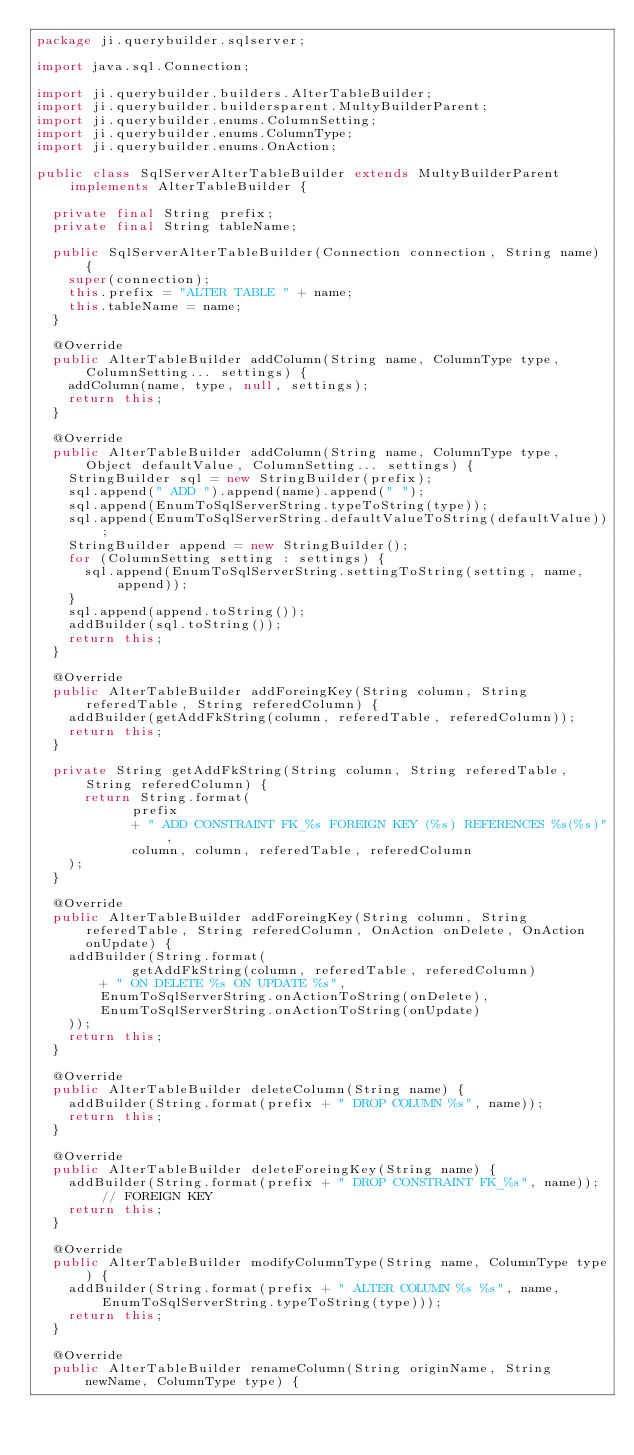Convert code to text. <code><loc_0><loc_0><loc_500><loc_500><_Java_>package ji.querybuilder.sqlserver;

import java.sql.Connection;

import ji.querybuilder.builders.AlterTableBuilder;
import ji.querybuilder.buildersparent.MultyBuilderParent;
import ji.querybuilder.enums.ColumnSetting;
import ji.querybuilder.enums.ColumnType;
import ji.querybuilder.enums.OnAction;

public class SqlServerAlterTableBuilder extends MultyBuilderParent implements AlterTableBuilder {

	private final String prefix;
	private final String tableName;
	
	public SqlServerAlterTableBuilder(Connection connection, String name) {
		super(connection);
		this.prefix = "ALTER TABLE " + name;
		this.tableName = name;
	}
	
	@Override
	public AlterTableBuilder addColumn(String name, ColumnType type, ColumnSetting... settings) {
		addColumn(name, type, null, settings);
		return this;
	}

	@Override
	public AlterTableBuilder addColumn(String name, ColumnType type, Object defaultValue, ColumnSetting... settings) {
		StringBuilder sql = new StringBuilder(prefix);
		sql.append(" ADD ").append(name).append(" ");
		sql.append(EnumToSqlServerString.typeToString(type));
		sql.append(EnumToSqlServerString.defaultValueToString(defaultValue));
		StringBuilder append = new StringBuilder();
		for (ColumnSetting setting : settings) {
			sql.append(EnumToSqlServerString.settingToString(setting, name, append));
		}
		sql.append(append.toString());
		addBuilder(sql.toString());
		return this;
	}

	@Override
	public AlterTableBuilder addForeingKey(String column, String referedTable, String referedColumn) {
		addBuilder(getAddFkString(column, referedTable, referedColumn));
		return this;
	}
	
	private String getAddFkString(String column, String referedTable, String referedColumn) {
	    return String.format(
		        prefix
		        + " ADD CONSTRAINT FK_%s FOREIGN KEY (%s) REFERENCES %s(%s)",
		        column, column, referedTable, referedColumn
		);
	}

	@Override
	public AlterTableBuilder addForeingKey(String column, String referedTable, String referedColumn, OnAction onDelete, OnAction onUpdate) {
		addBuilder(String.format(
		        getAddFkString(column, referedTable, referedColumn)
				+ " ON DELETE %s ON UPDATE %s",
				EnumToSqlServerString.onActionToString(onDelete),
				EnumToSqlServerString.onActionToString(onUpdate)
		));
		return this;
	}

	@Override
	public AlterTableBuilder deleteColumn(String name) {
		addBuilder(String.format(prefix + " DROP COLUMN %s", name));
		return this;
	}

	@Override
	public AlterTableBuilder deleteForeingKey(String name) {
		addBuilder(String.format(prefix + " DROP CONSTRAINT FK_%s", name)); // FOREIGN KEY
		return this;
	}

	@Override
	public AlterTableBuilder modifyColumnType(String name, ColumnType type) {
		addBuilder(String.format(prefix + " ALTER COLUMN %s %s", name, EnumToSqlServerString.typeToString(type)));
		return this;
	}

	@Override
	public AlterTableBuilder renameColumn(String originName, String newName, ColumnType type) {</code> 